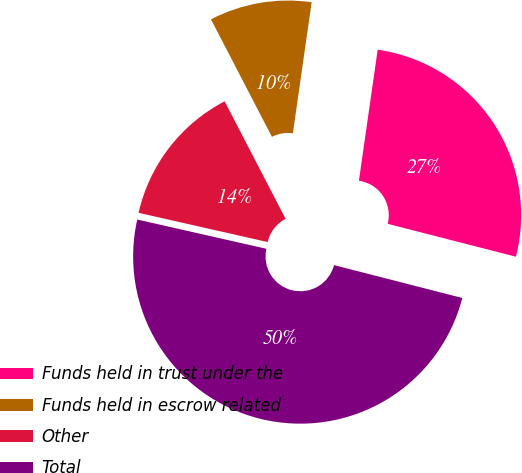Convert chart. <chart><loc_0><loc_0><loc_500><loc_500><pie_chart><fcel>Funds held in trust under the<fcel>Funds held in escrow related<fcel>Other<fcel>Total<nl><fcel>26.73%<fcel>9.88%<fcel>13.84%<fcel>49.55%<nl></chart> 